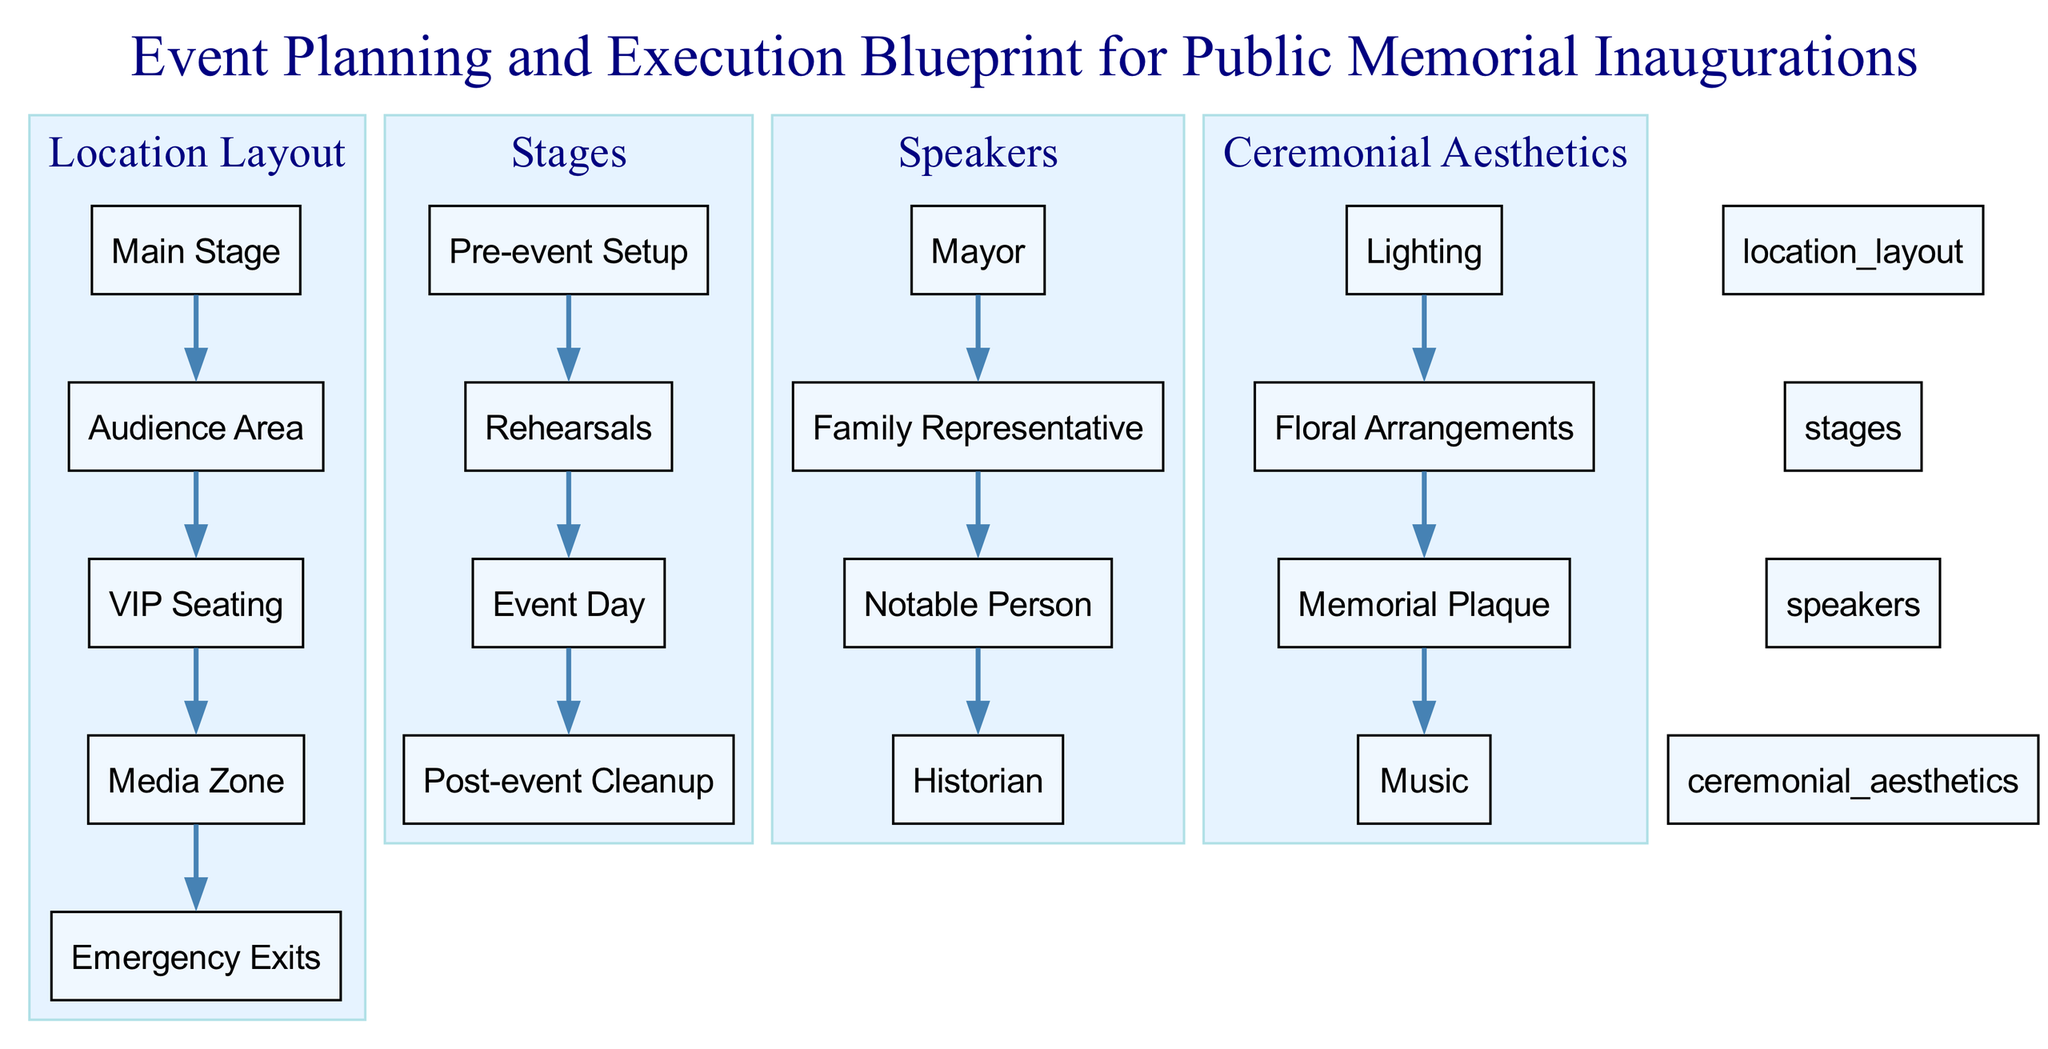What is the main stage labeled as? The node labeled "Main Stage" is found under the "Location Layout" section. This label represents the focal point of the event where most activities will occur.
Answer: Main Stage How many types of speakers are identified in the diagram? The "Speakers" section includes four distinct roles: Mayor, Family Representative, Notable Person, and Historian. Counting these gives us a total of four types of speakers involved in the memorial inauguration.
Answer: 4 Which area is designated for VIP attendees? Under the "Location Layout" section, there is a node specifically labeled "VIP Seating," indicating the designated area for very important people at the event.
Answer: VIP Seating What is the last stage listed in the event timeline? The "Stages" section outlines a sequence that starts from "Pre-event Setup" and concludes with "Post-event Cleanup." Hence, the last stage is the cleanup stage after the event has concluded.
Answer: Post-event Cleanup Which ceremonial aesthetic involves floral elements? Within the "Ceremonial Aesthetics" section, the node labeled "Floral Arrangements" explicitly mentions the use of flowers in the memorial ceremony, thus connecting aesthetics to nature.
Answer: Floral Arrangements What is the connection between the "Audience Area" and "Main Stage"? The diagram indicates that the "Audience Area" directly relates to the "Main Stage" as it is positioned for spectators to view the activities happening on the main stage, making it a critical part of the layout.
Answer: Direct relationship Which node illustrates the purpose of lighting during the event? In the "Ceremonial Aesthetics" section, the node labeled "Lighting" represents the importance of lighting in enhancing the event's ambiance, contributing to aesthetics and atmosphere.
Answer: Lighting How many elements are part of the location layout? The "Location Layout" section consists of five nodes: Main Stage, Audience Area, VIP Seating, Media Zone, and Emergency Exits. Thus, the total number of elements in this layout is five.
Answer: 5 